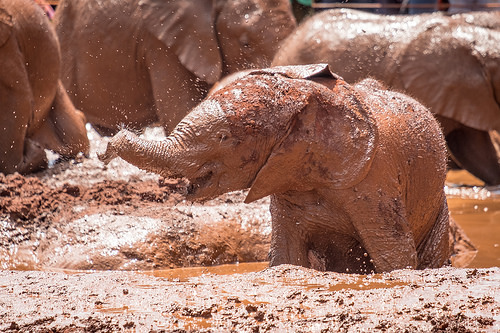<image>
Is the elephant in the mud? Yes. The elephant is contained within or inside the mud, showing a containment relationship. 